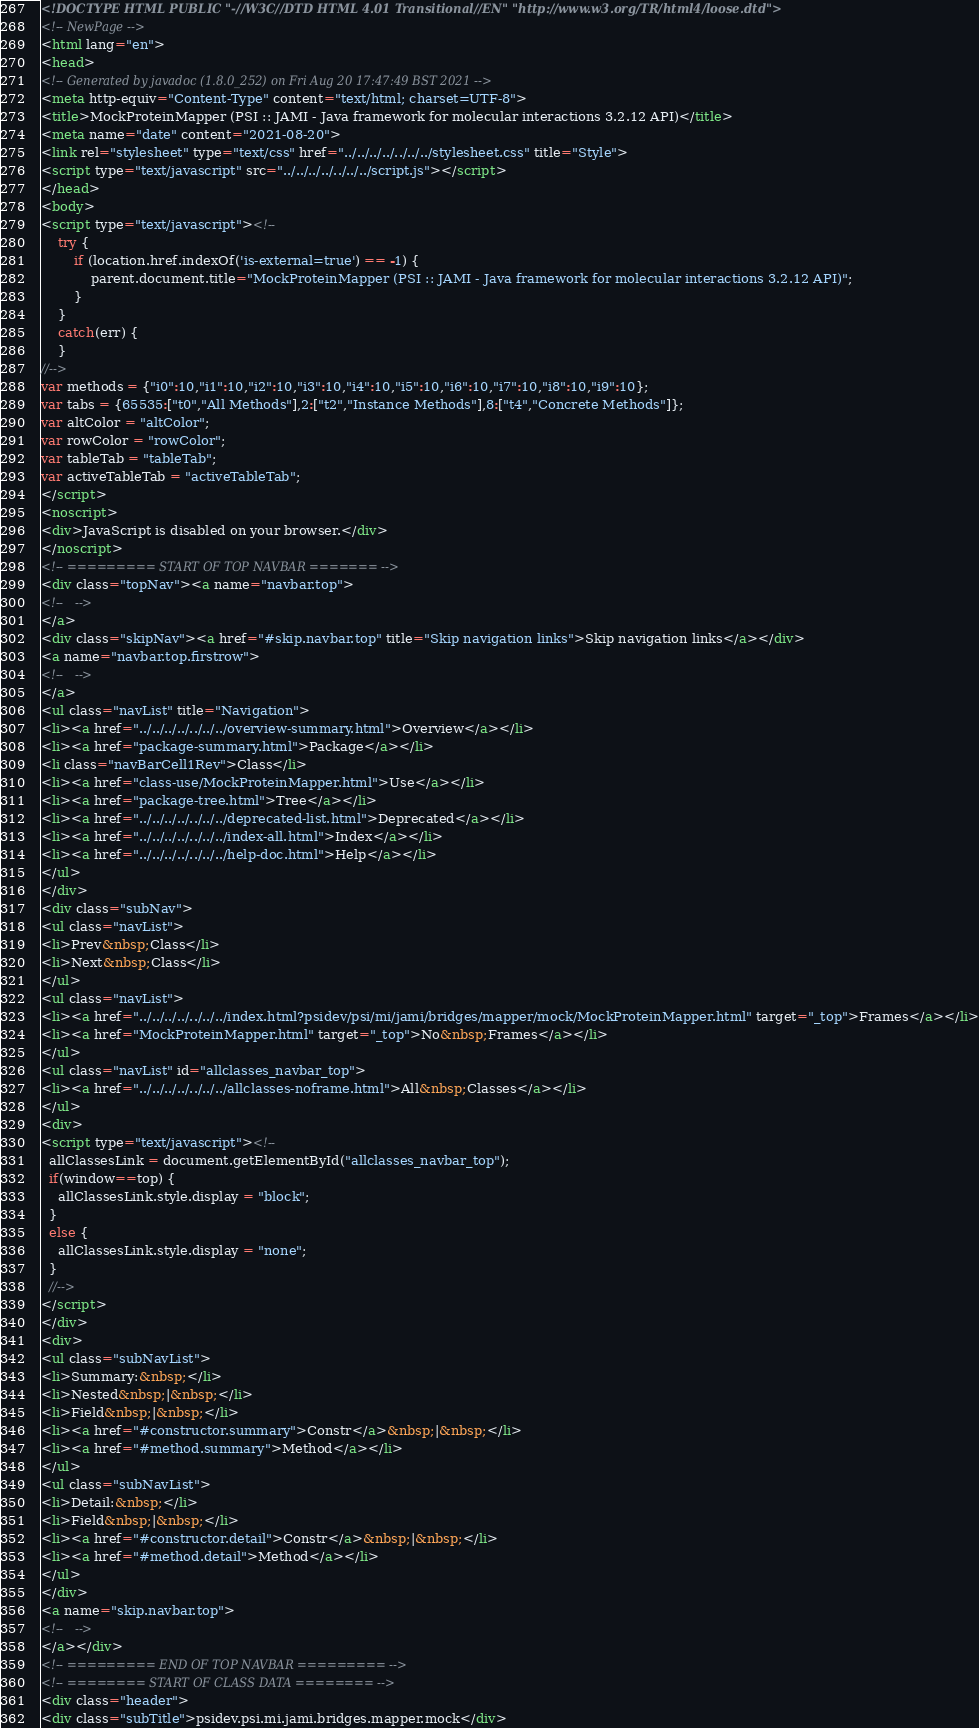Convert code to text. <code><loc_0><loc_0><loc_500><loc_500><_HTML_><!DOCTYPE HTML PUBLIC "-//W3C//DTD HTML 4.01 Transitional//EN" "http://www.w3.org/TR/html4/loose.dtd">
<!-- NewPage -->
<html lang="en">
<head>
<!-- Generated by javadoc (1.8.0_252) on Fri Aug 20 17:47:49 BST 2021 -->
<meta http-equiv="Content-Type" content="text/html; charset=UTF-8">
<title>MockProteinMapper (PSI :: JAMI - Java framework for molecular interactions 3.2.12 API)</title>
<meta name="date" content="2021-08-20">
<link rel="stylesheet" type="text/css" href="../../../../../../../stylesheet.css" title="Style">
<script type="text/javascript" src="../../../../../../../script.js"></script>
</head>
<body>
<script type="text/javascript"><!--
    try {
        if (location.href.indexOf('is-external=true') == -1) {
            parent.document.title="MockProteinMapper (PSI :: JAMI - Java framework for molecular interactions 3.2.12 API)";
        }
    }
    catch(err) {
    }
//-->
var methods = {"i0":10,"i1":10,"i2":10,"i3":10,"i4":10,"i5":10,"i6":10,"i7":10,"i8":10,"i9":10};
var tabs = {65535:["t0","All Methods"],2:["t2","Instance Methods"],8:["t4","Concrete Methods"]};
var altColor = "altColor";
var rowColor = "rowColor";
var tableTab = "tableTab";
var activeTableTab = "activeTableTab";
</script>
<noscript>
<div>JavaScript is disabled on your browser.</div>
</noscript>
<!-- ========= START OF TOP NAVBAR ======= -->
<div class="topNav"><a name="navbar.top">
<!--   -->
</a>
<div class="skipNav"><a href="#skip.navbar.top" title="Skip navigation links">Skip navigation links</a></div>
<a name="navbar.top.firstrow">
<!--   -->
</a>
<ul class="navList" title="Navigation">
<li><a href="../../../../../../../overview-summary.html">Overview</a></li>
<li><a href="package-summary.html">Package</a></li>
<li class="navBarCell1Rev">Class</li>
<li><a href="class-use/MockProteinMapper.html">Use</a></li>
<li><a href="package-tree.html">Tree</a></li>
<li><a href="../../../../../../../deprecated-list.html">Deprecated</a></li>
<li><a href="../../../../../../../index-all.html">Index</a></li>
<li><a href="../../../../../../../help-doc.html">Help</a></li>
</ul>
</div>
<div class="subNav">
<ul class="navList">
<li>Prev&nbsp;Class</li>
<li>Next&nbsp;Class</li>
</ul>
<ul class="navList">
<li><a href="../../../../../../../index.html?psidev/psi/mi/jami/bridges/mapper/mock/MockProteinMapper.html" target="_top">Frames</a></li>
<li><a href="MockProteinMapper.html" target="_top">No&nbsp;Frames</a></li>
</ul>
<ul class="navList" id="allclasses_navbar_top">
<li><a href="../../../../../../../allclasses-noframe.html">All&nbsp;Classes</a></li>
</ul>
<div>
<script type="text/javascript"><!--
  allClassesLink = document.getElementById("allclasses_navbar_top");
  if(window==top) {
    allClassesLink.style.display = "block";
  }
  else {
    allClassesLink.style.display = "none";
  }
  //-->
</script>
</div>
<div>
<ul class="subNavList">
<li>Summary:&nbsp;</li>
<li>Nested&nbsp;|&nbsp;</li>
<li>Field&nbsp;|&nbsp;</li>
<li><a href="#constructor.summary">Constr</a>&nbsp;|&nbsp;</li>
<li><a href="#method.summary">Method</a></li>
</ul>
<ul class="subNavList">
<li>Detail:&nbsp;</li>
<li>Field&nbsp;|&nbsp;</li>
<li><a href="#constructor.detail">Constr</a>&nbsp;|&nbsp;</li>
<li><a href="#method.detail">Method</a></li>
</ul>
</div>
<a name="skip.navbar.top">
<!--   -->
</a></div>
<!-- ========= END OF TOP NAVBAR ========= -->
<!-- ======== START OF CLASS DATA ======== -->
<div class="header">
<div class="subTitle">psidev.psi.mi.jami.bridges.mapper.mock</div></code> 